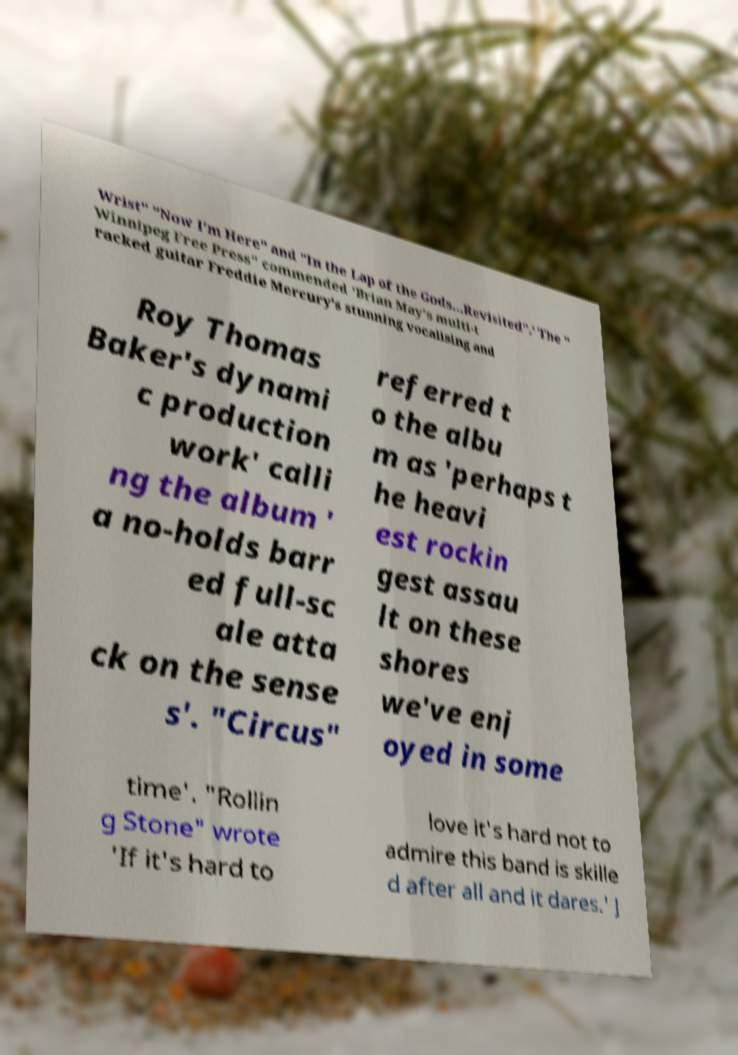Could you extract and type out the text from this image? Wrist" "Now I'm Here" and "In the Lap of the Gods...Revisited".' The " Winnipeg Free Press" commended 'Brian May's multi-t racked guitar Freddie Mercury's stunning vocalising and Roy Thomas Baker's dynami c production work' calli ng the album ' a no-holds barr ed full-sc ale atta ck on the sense s'. "Circus" referred t o the albu m as 'perhaps t he heavi est rockin gest assau lt on these shores we've enj oyed in some time'. "Rollin g Stone" wrote 'If it's hard to love it's hard not to admire this band is skille d after all and it dares.' J 